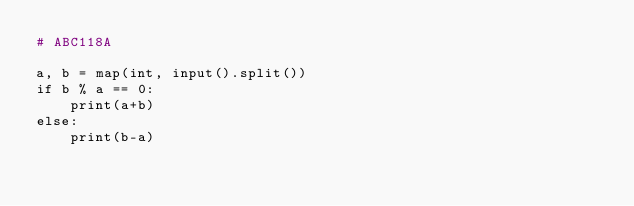Convert code to text. <code><loc_0><loc_0><loc_500><loc_500><_Python_># ABC118A

a, b = map(int, input().split())
if b % a == 0:
    print(a+b)
else:
    print(b-a)
</code> 